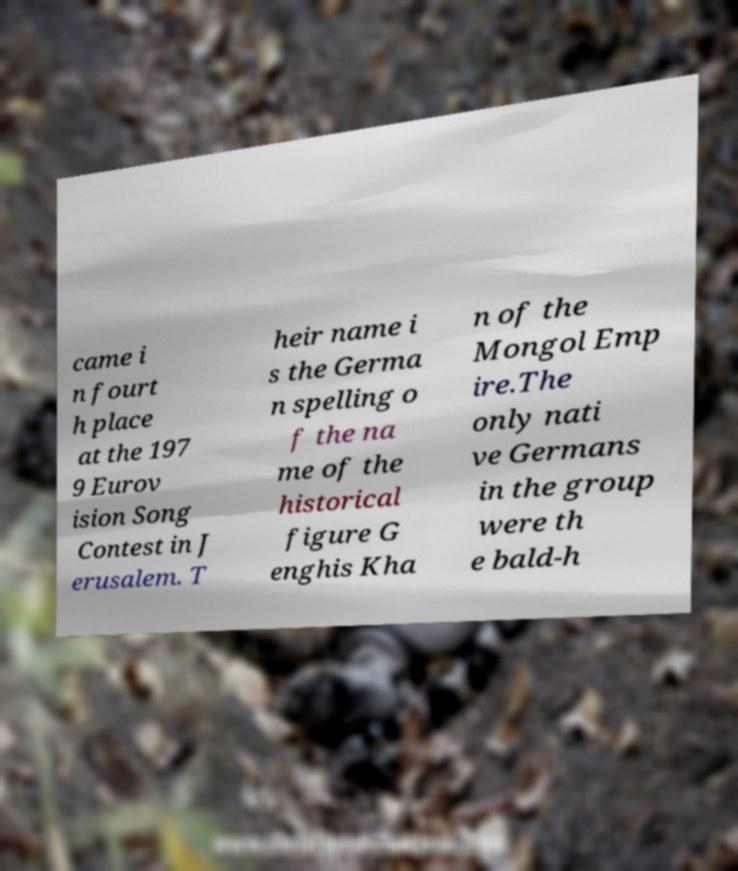Can you read and provide the text displayed in the image?This photo seems to have some interesting text. Can you extract and type it out for me? came i n fourt h place at the 197 9 Eurov ision Song Contest in J erusalem. T heir name i s the Germa n spelling o f the na me of the historical figure G enghis Kha n of the Mongol Emp ire.The only nati ve Germans in the group were th e bald-h 